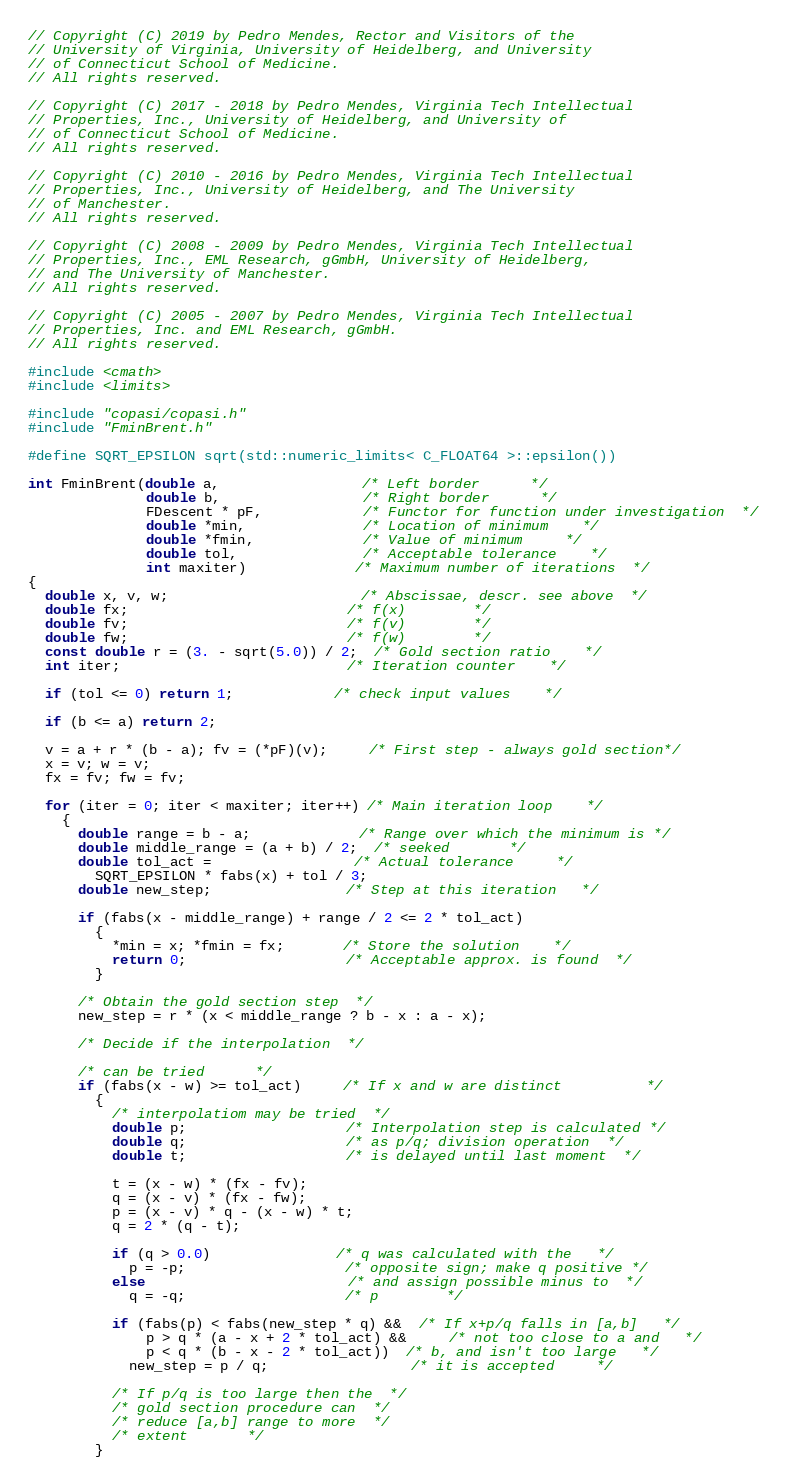Convert code to text. <code><loc_0><loc_0><loc_500><loc_500><_C++_>// Copyright (C) 2019 by Pedro Mendes, Rector and Visitors of the
// University of Virginia, University of Heidelberg, and University
// of Connecticut School of Medicine.
// All rights reserved.

// Copyright (C) 2017 - 2018 by Pedro Mendes, Virginia Tech Intellectual
// Properties, Inc., University of Heidelberg, and University of
// of Connecticut School of Medicine.
// All rights reserved.

// Copyright (C) 2010 - 2016 by Pedro Mendes, Virginia Tech Intellectual
// Properties, Inc., University of Heidelberg, and The University
// of Manchester.
// All rights reserved.

// Copyright (C) 2008 - 2009 by Pedro Mendes, Virginia Tech Intellectual
// Properties, Inc., EML Research, gGmbH, University of Heidelberg,
// and The University of Manchester.
// All rights reserved.

// Copyright (C) 2005 - 2007 by Pedro Mendes, Virginia Tech Intellectual
// Properties, Inc. and EML Research, gGmbH.
// All rights reserved.

#include <cmath>
#include <limits>

#include "copasi/copasi.h"
#include "FminBrent.h"

#define SQRT_EPSILON sqrt(std::numeric_limits< C_FLOAT64 >::epsilon())

int FminBrent(double a,                 /* Left border      */
              double b,                 /* Right border      */
              FDescent * pF,            /* Functor for function under investigation  */
              double *min,              /* Location of minimum    */
              double *fmin,             /* Value of minimum     */
              double tol,               /* Acceptable tolerance    */
              int maxiter)             /* Maximum number of iterations  */
{
  double x, v, w;                       /* Abscissae, descr. see above  */
  double fx;                          /* f(x)        */
  double fv;                          /* f(v)        */
  double fw;                          /* f(w)        */
  const double r = (3. - sqrt(5.0)) / 2;  /* Gold section ratio    */
  int iter;                           /* Iteration counter    */

  if (tol <= 0) return 1;            /* check input values    */

  if (b <= a) return 2;

  v = a + r * (b - a); fv = (*pF)(v);     /* First step - always gold section*/
  x = v; w = v;
  fx = fv; fw = fv;

  for (iter = 0; iter < maxiter; iter++) /* Main iteration loop    */
    {
      double range = b - a;             /* Range over which the minimum is */
      double middle_range = (a + b) / 2;  /* seeked       */
      double tol_act =                 /* Actual tolerance     */
        SQRT_EPSILON * fabs(x) + tol / 3;
      double new_step;                /* Step at this iteration   */

      if (fabs(x - middle_range) + range / 2 <= 2 * tol_act)
        {
          *min = x; *fmin = fx;       /* Store the solution    */
          return 0;                   /* Acceptable approx. is found  */
        }

      /* Obtain the gold section step  */
      new_step = r * (x < middle_range ? b - x : a - x);

      /* Decide if the interpolation  */

      /* can be tried      */
      if (fabs(x - w) >= tol_act)     /* If x and w are distinct          */
        {
          /* interpolatiom may be tried  */
          double p;                   /* Interpolation step is calculated */
          double q;                   /* as p/q; division operation  */
          double t;                   /* is delayed until last moment  */

          t = (x - w) * (fx - fv);
          q = (x - v) * (fx - fw);
          p = (x - v) * q - (x - w) * t;
          q = 2 * (q - t);

          if (q > 0.0)               /* q was calculated with the   */
            p = -p;                   /* opposite sign; make q positive */
          else                        /* and assign possible minus to  */
            q = -q;                   /* p        */

          if (fabs(p) < fabs(new_step * q) &&  /* If x+p/q falls in [a,b]   */
              p > q * (a - x + 2 * tol_act) &&     /* not too close to a and   */
              p < q * (b - x - 2 * tol_act))  /* b, and isn't too large   */
            new_step = p / q;                 /* it is accepted     */

          /* If p/q is too large then the  */
          /* gold section procedure can  */
          /* reduce [a,b] range to more  */
          /* extent       */
        }
</code> 